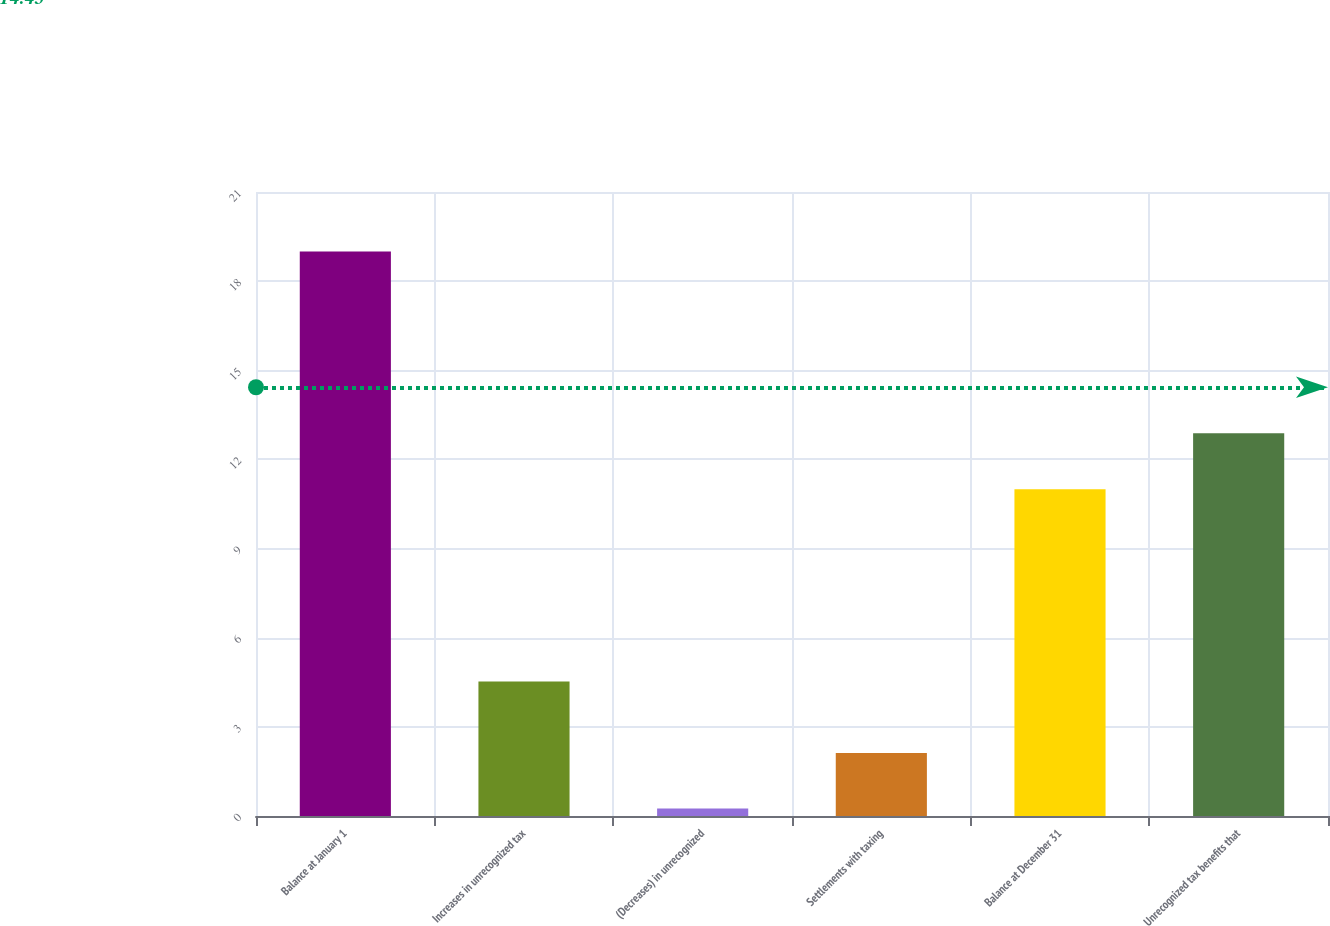<chart> <loc_0><loc_0><loc_500><loc_500><bar_chart><fcel>Balance at January 1<fcel>Increases in unrecognized tax<fcel>(Decreases) in unrecognized<fcel>Settlements with taxing<fcel>Balance at December 31<fcel>Unrecognized tax benefits that<nl><fcel>19<fcel>4.53<fcel>0.25<fcel>2.12<fcel>11<fcel>12.88<nl></chart> 